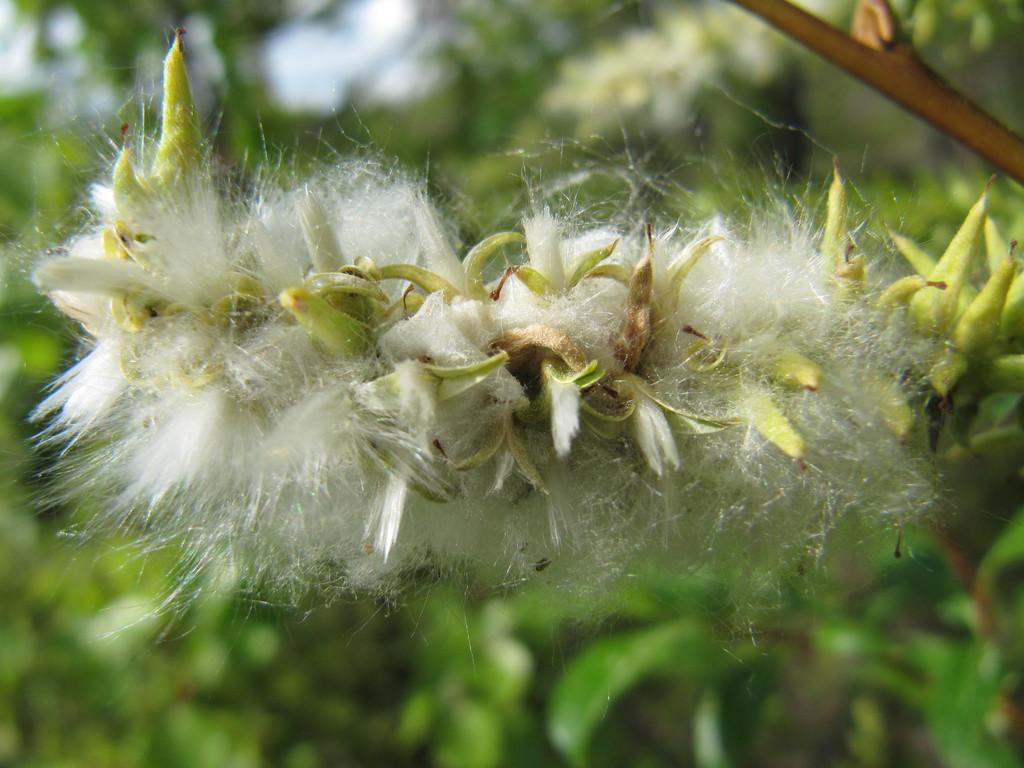What is the main subject in the image? There is a white color thing in the image. Can you describe the background of the image? The background of the image is blurred. Is there a border surrounding the white color thing in the image? There is no mention of a border in the provided facts, so we cannot determine if one is present. Can you see a throne in the image? There is no mention of a throne in the provided facts, so we cannot determine if one is present. 